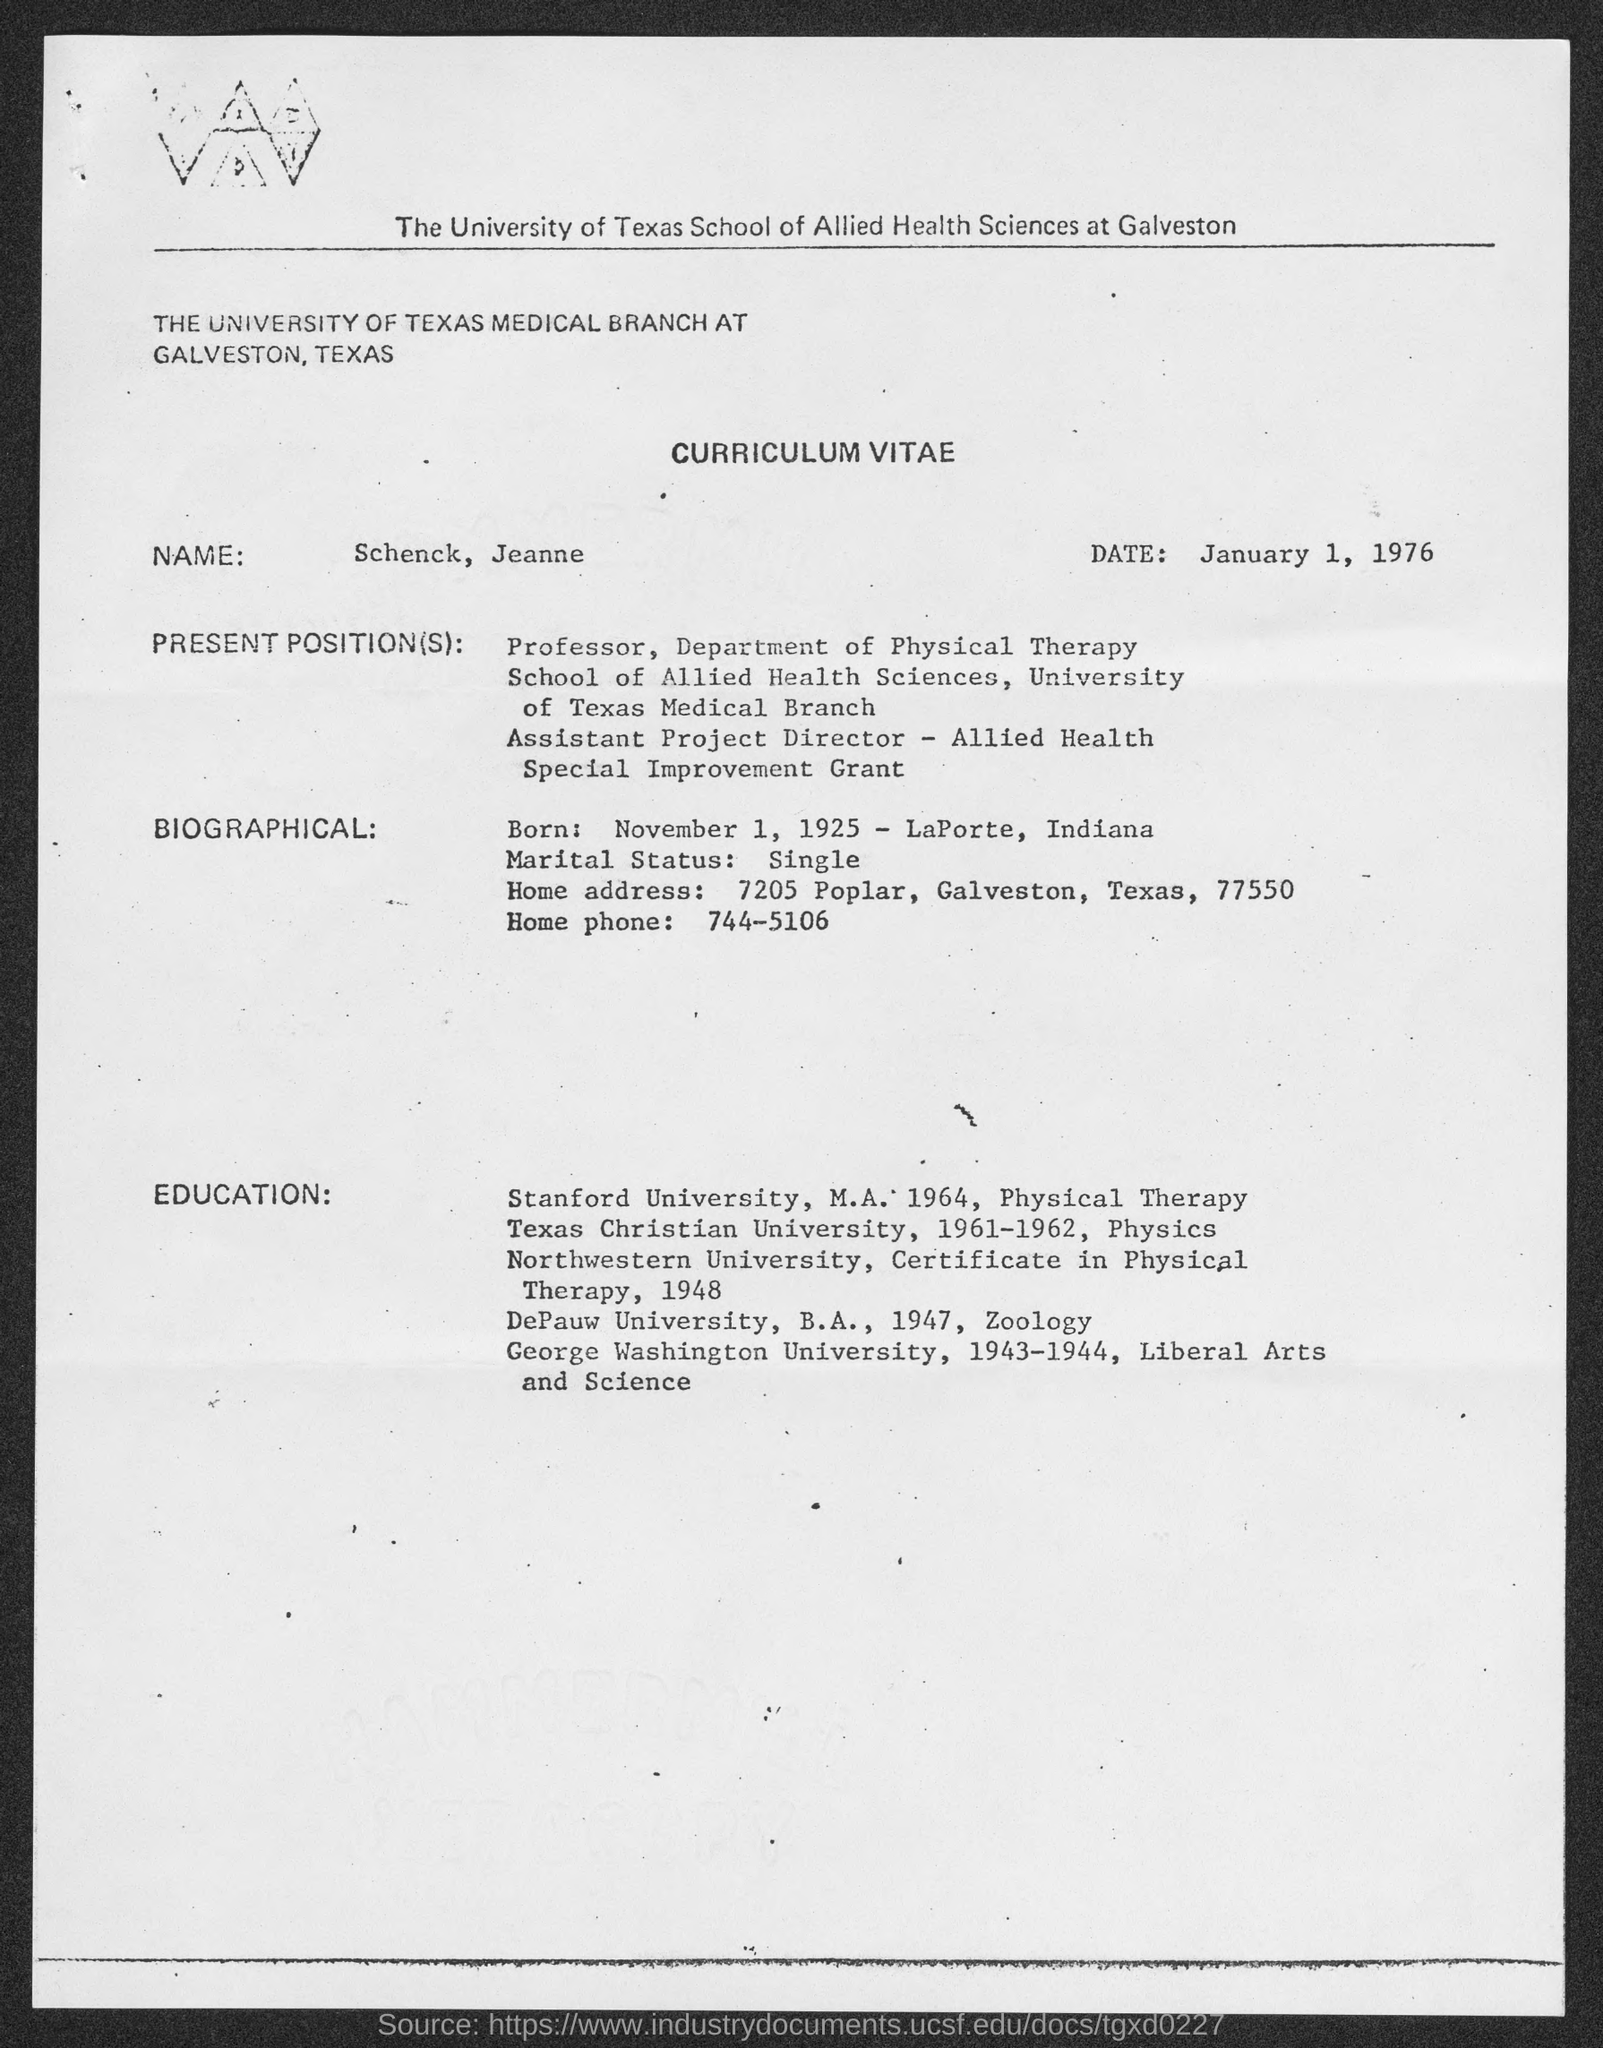What is the Date?
Provide a short and direct response. January 1, 1976. What is the Name?
Provide a short and direct response. Schenck, Jeanne. When was he born?
Provide a short and direct response. November 1, 1925. What is the marital status?
Give a very brief answer. Single. What is the Home Phone?
Offer a terse response. 744-5106. What is the Home Address?
Your answer should be very brief. 7205 Poplar, Galveston, Texas, 77550. 